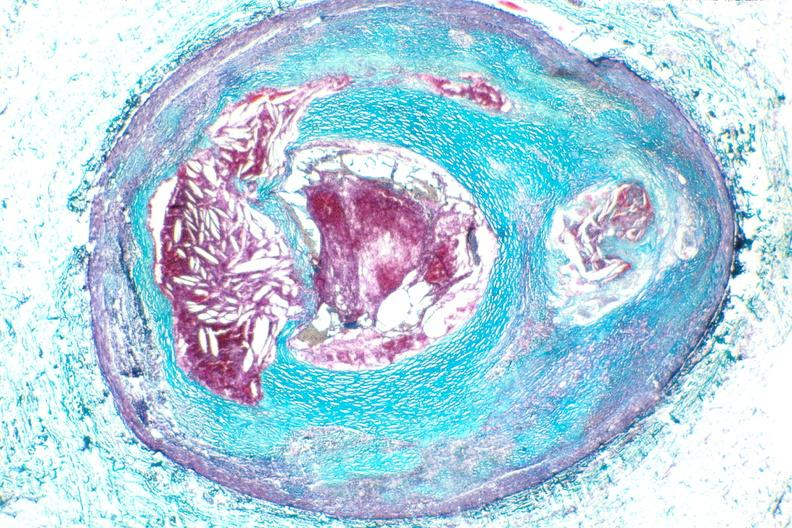what is present?
Answer the question using a single word or phrase. Cardiovascular 